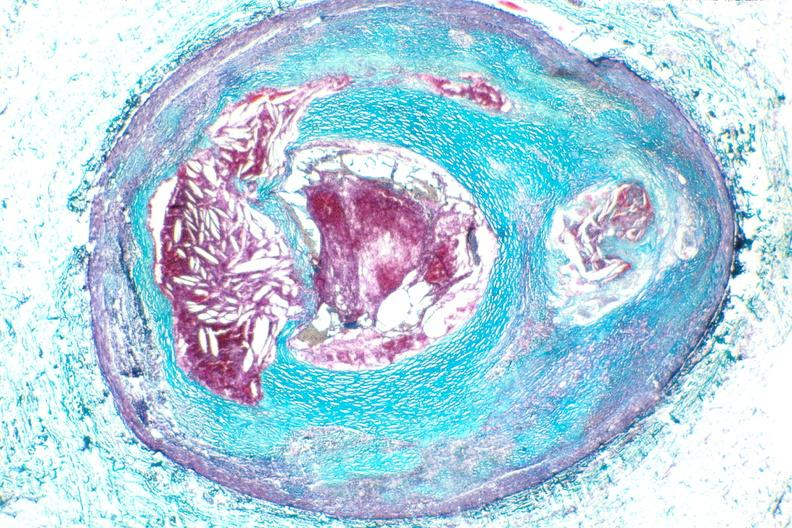what is present?
Answer the question using a single word or phrase. Cardiovascular 